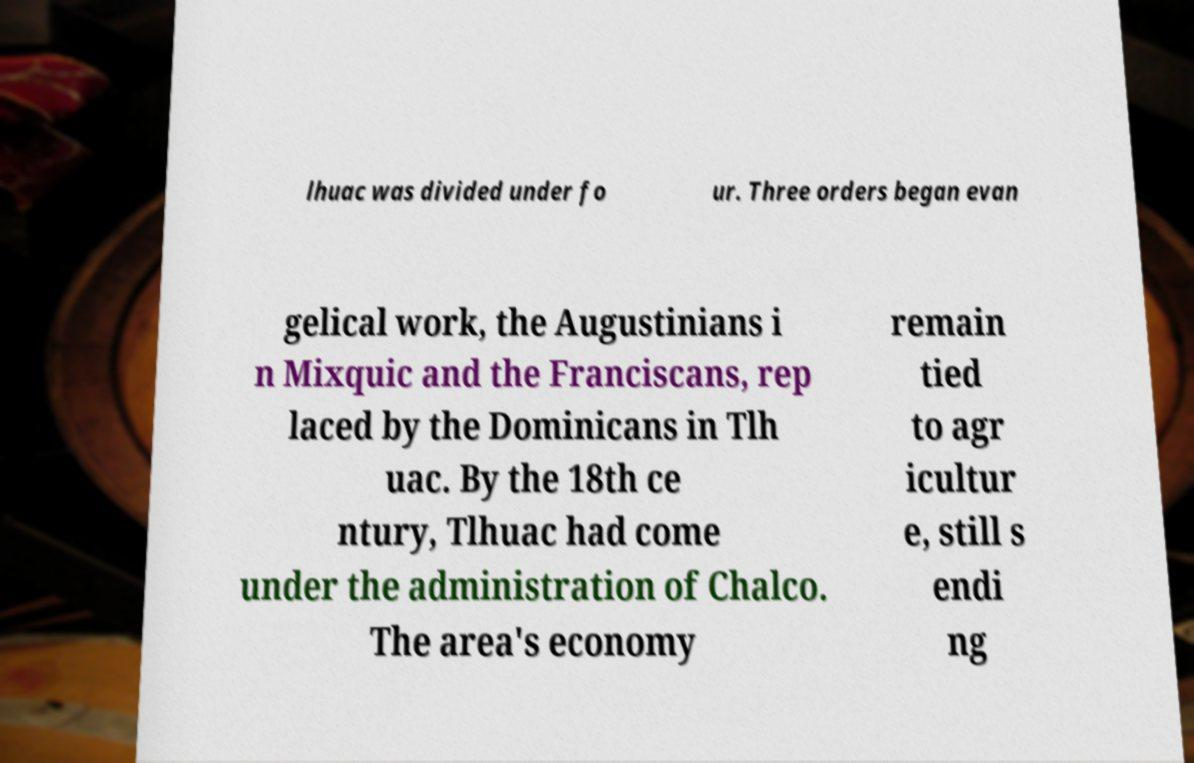Please identify and transcribe the text found in this image. lhuac was divided under fo ur. Three orders began evan gelical work, the Augustinians i n Mixquic and the Franciscans, rep laced by the Dominicans in Tlh uac. By the 18th ce ntury, Tlhuac had come under the administration of Chalco. The area's economy remain tied to agr icultur e, still s endi ng 